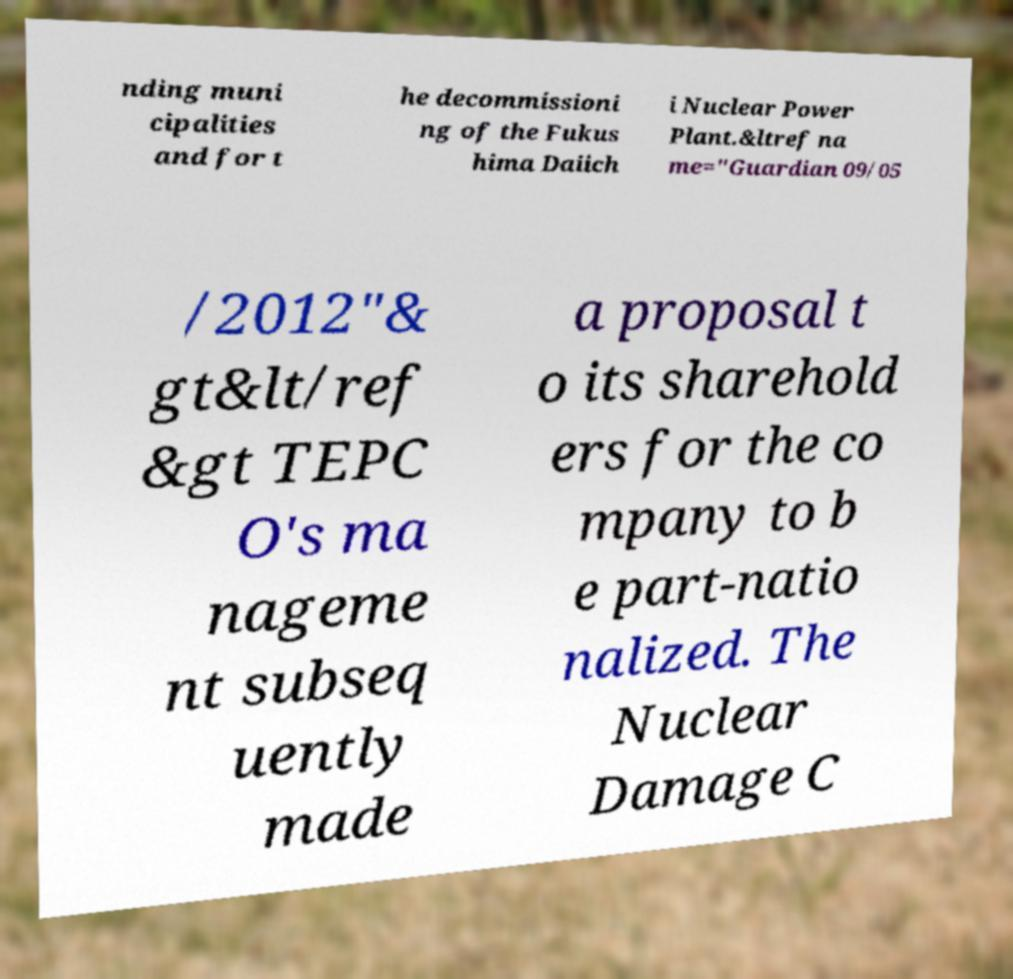What messages or text are displayed in this image? I need them in a readable, typed format. nding muni cipalities and for t he decommissioni ng of the Fukus hima Daiich i Nuclear Power Plant.&ltref na me="Guardian 09/05 /2012"& gt&lt/ref &gt TEPC O's ma nageme nt subseq uently made a proposal t o its sharehold ers for the co mpany to b e part-natio nalized. The Nuclear Damage C 